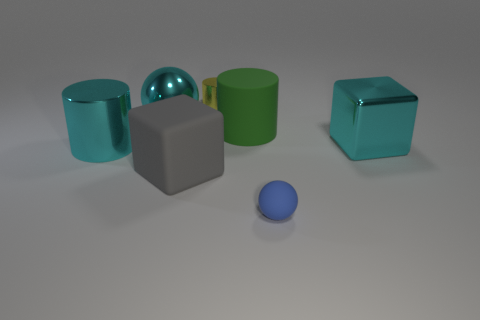Are there more tiny yellow things that are in front of the big cyan shiny sphere than large metal balls?
Provide a short and direct response. No. Are there any cylinders in front of the cube that is on the right side of the large matte thing that is on the right side of the tiny shiny cylinder?
Offer a terse response. Yes. Are there any large matte cylinders on the right side of the big gray matte object?
Provide a short and direct response. Yes. What number of big shiny cubes have the same color as the large shiny cylinder?
Give a very brief answer. 1. There is a cyan cylinder that is the same material as the large ball; what size is it?
Ensure brevity in your answer.  Large. There is a cyan thing that is right of the ball that is left of the tiny thing that is on the right side of the green matte cylinder; what size is it?
Give a very brief answer. Large. There is a ball right of the big gray block; what is its size?
Offer a very short reply. Small. What number of cyan objects are either large metallic objects or small matte spheres?
Keep it short and to the point. 3. Is there a metallic sphere of the same size as the rubber cylinder?
Offer a very short reply. Yes. There is a yellow cylinder that is the same size as the matte sphere; what is it made of?
Give a very brief answer. Metal. 